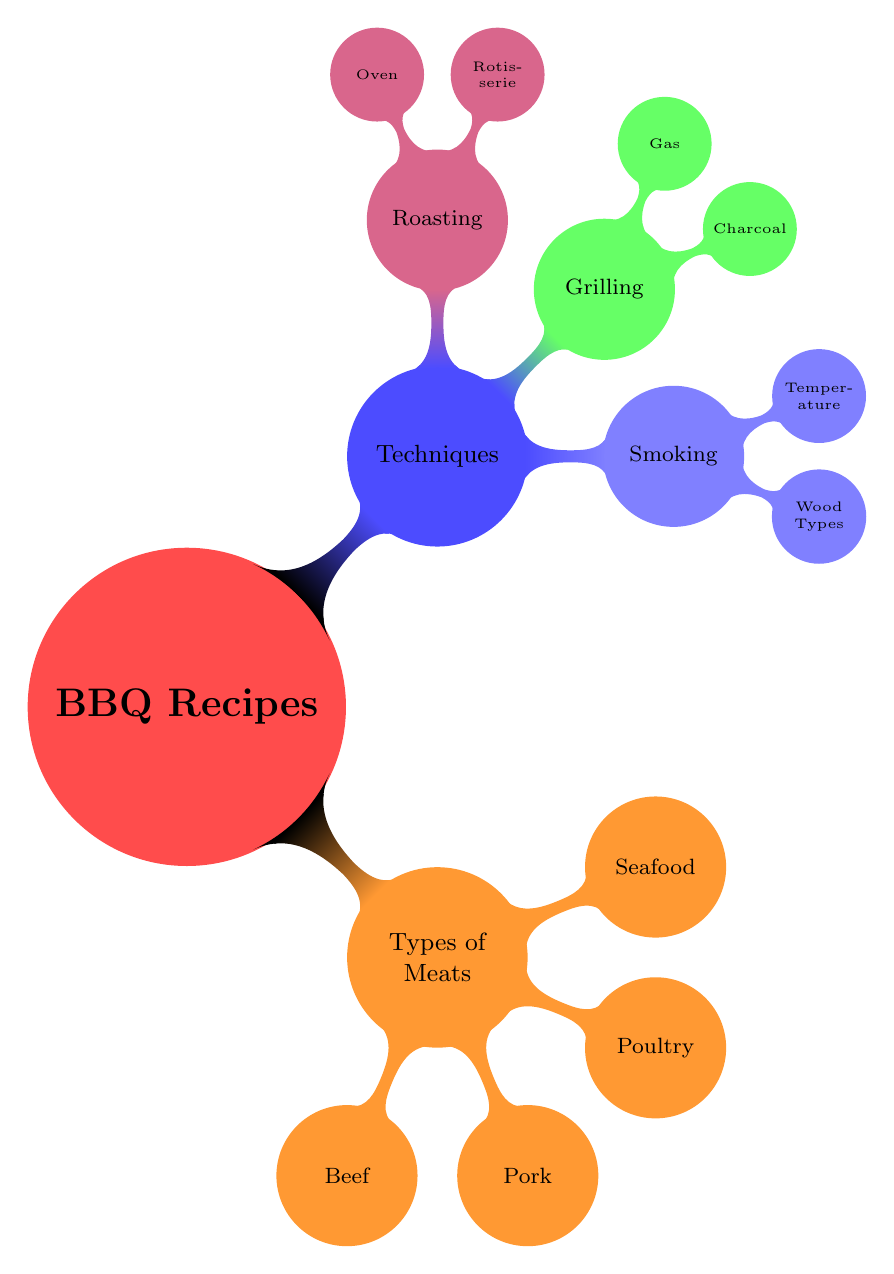What are the four main types of meats listed? The diagram categorizes BBQ recipes into two main sections: "Types of Meats" and "Techniques." Under "Types of Meats," there are four categories mentioned: Beef, Pork, Poultry, and Seafood.
Answer: Beef, Pork, Poultry, Seafood How many techniques are mentioned in the diagram? Under the "Techniques" section, there are three distinct techniques listed: Smoking, Grilling, and Roasting. Thus, we count a total of three techniques.
Answer: 3 What wood types are used in smoking? The diagram specifies two nodes under "Smoking" that lead to "Wood Types." The three specific wood types listed are Hickory, Applewood, and Mesquite.
Answer: Hickory, Applewood, Mesquite Which type of grilling involves indirect heat? In the "Grilling" section, specifically under "Charcoal," there is a sub-node labeled "Indirect Heat." This means indirect heat is part of the Charcoal Grilling technique.
Answer: Charcoal Grilling What type of meat is prepared using rotisserie? From the "Roasting" section, under the "Rotisserie" node, there's a specific mention of "Whole Chicken." Therefore, whole chicken is prepared using the rotisserie technique.
Answer: Whole Chicken Which technique has a higher cooking temperature: Smoking or Grilling? By examining both sections, "Smoking" mentions "Low and Slow" and "Hot and Fast," which indicates a slower cooking technique. In contrast, "Grilling" has a sub-node for "High Heat," suggesting a higher cooking temperature overall in grilling compared to smoking.
Answer: Grilling How many types of seafood are mentioned? Under "Types of Meats," the "Seafood" subsection lists three specific types: Salmon, Shrimp, and Scallops. Thus, the total number of seafood types mentioned is three.
Answer: 3 What are the two ways to cook pork in the oven? The "Oven Roasting" sub-node under "Roasting" lists two specific types: "Pork Loin" and "Duck." Hence, these are the two ways mentioned to cook pork in the oven.
Answer: Pork Loin What is the first sub-node listed under Techniques? The first child node of the "Techniques" section is "Smoking." This indicates that smoking is the first technique categorized under the Techniques section.
Answer: Smoking 